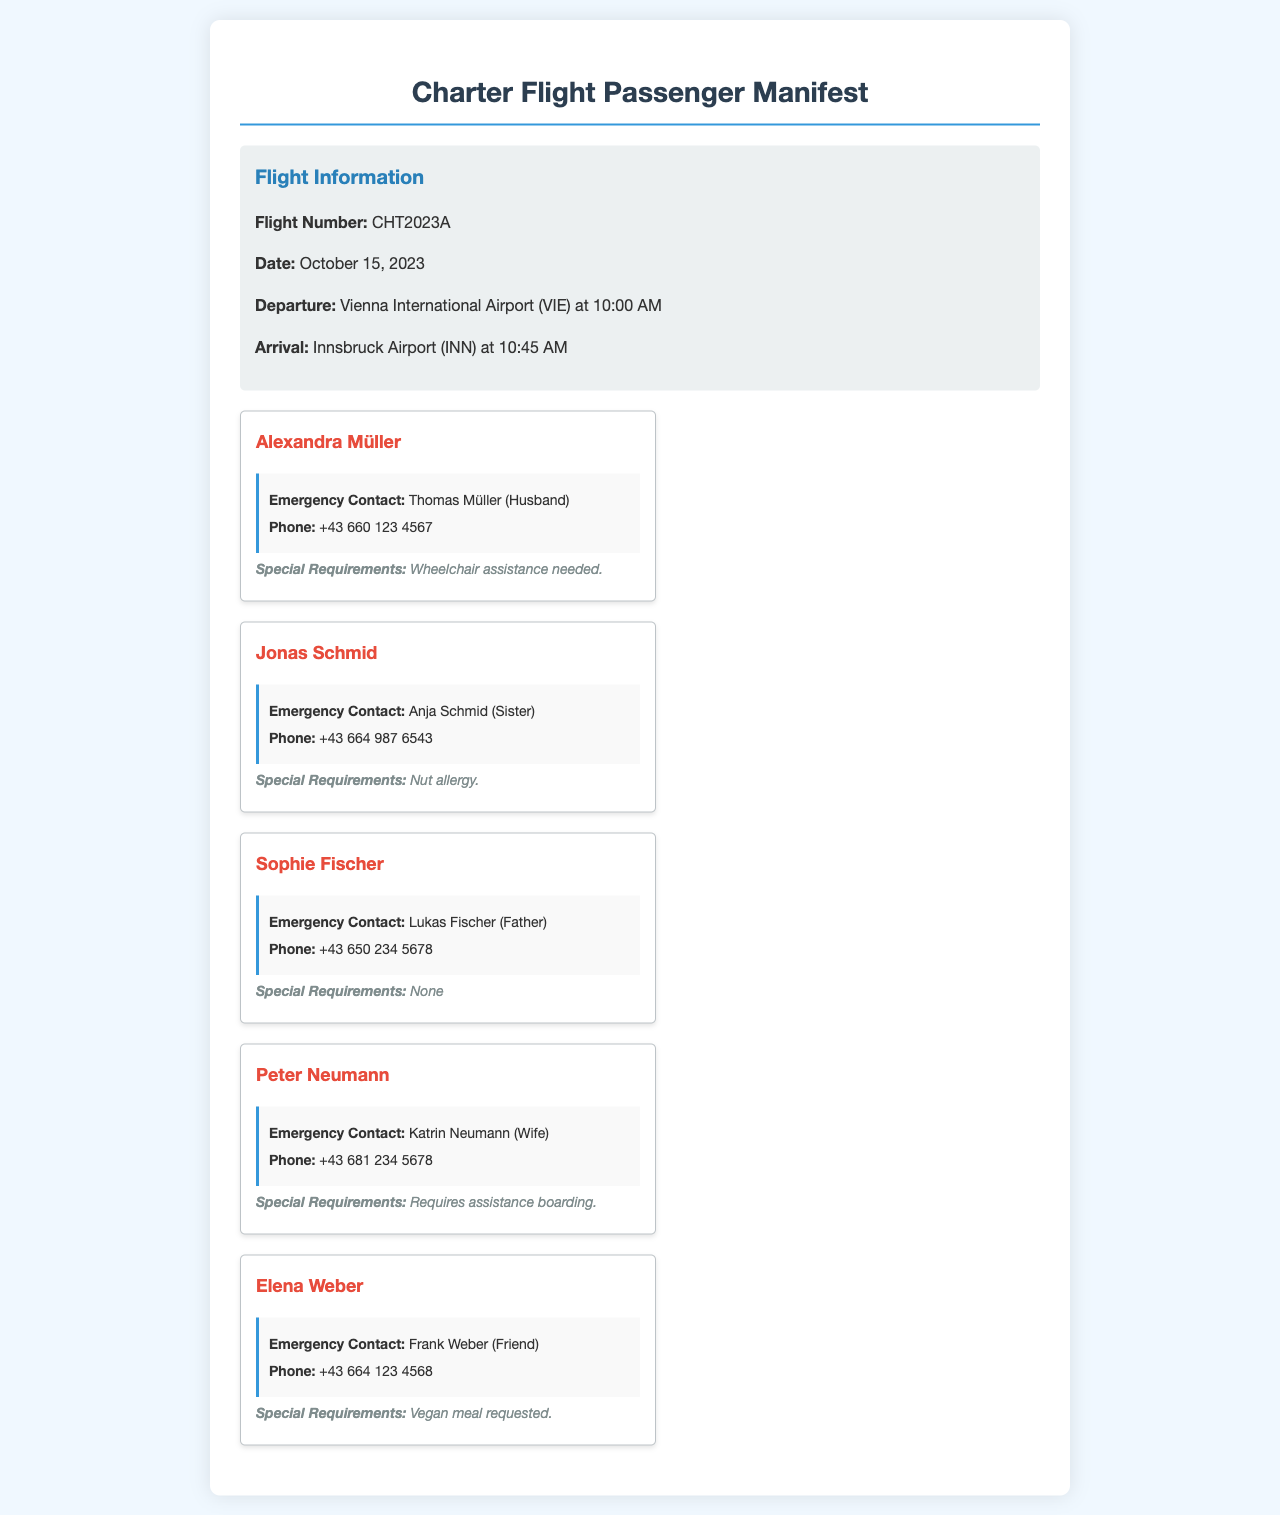What is the flight number? The flight number is indicated in the flight details section of the document.
Answer: CHT2023A What date is the flight scheduled? The date is provided in the flight details section of the document.
Answer: October 15, 2023 Who is the emergency contact for Alexandra Müller? The emergency contact information is listed under each passenger's details in the document.
Answer: Thomas Müller (Husband) What special requirement does Jonas Schmid have? Special requirements are listed for each passenger in the document.
Answer: Nut allergy How many passengers are listed in the manifest? The number of passenger cards in the document indicates the total passengers.
Answer: Five Which airport is the flight departing from? The departure airport is mentioned in the flight details of the document.
Answer: Vienna International Airport (VIE) Who requires assistance boarding? The specific requirements for each passenger are detailed in their individual cards.
Answer: Peter Neumann What type of meal did Elena Weber request? The meal preferences are noted in the special requirements section for each passenger.
Answer: Vegan meal requested What is the phone number of Sophie Fischer's emergency contact? The phone number is included in the emergency contact section of the document.
Answer: +43 650 234 5678 What time does the flight arrive? The arrival time is specified in the flight details section of the document.
Answer: 10:45 AM 